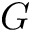<formula> <loc_0><loc_0><loc_500><loc_500>G</formula> 